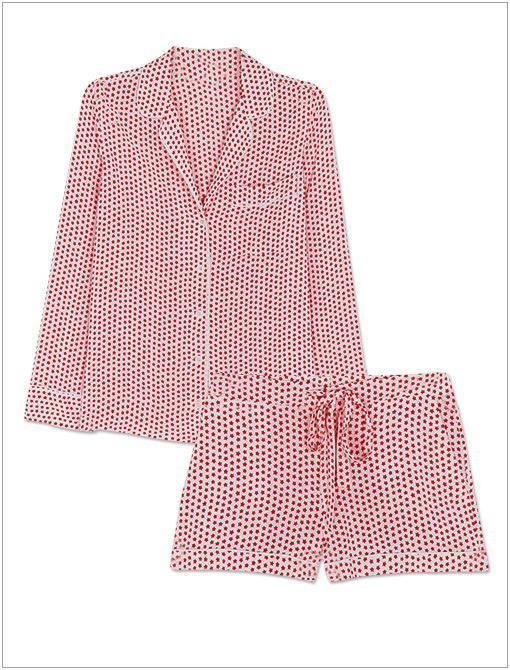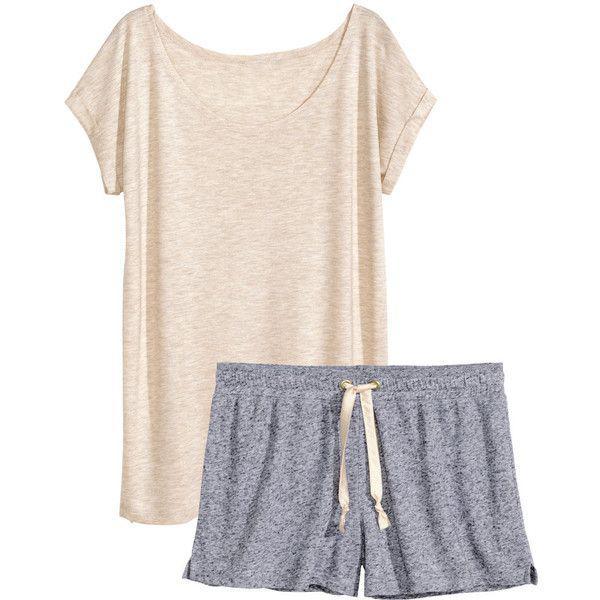The first image is the image on the left, the second image is the image on the right. Considering the images on both sides, is "there is a single pair of pajamas with short sleeves and long pants" valid? Answer yes or no. No. The first image is the image on the left, the second image is the image on the right. Evaluate the accuracy of this statement regarding the images: "Each image contains one sleepwear outfit consisting of a patterned top and matching pants, but one outfit has long sleeves while the other has short ruffled sleeves.". Is it true? Answer yes or no. No. 